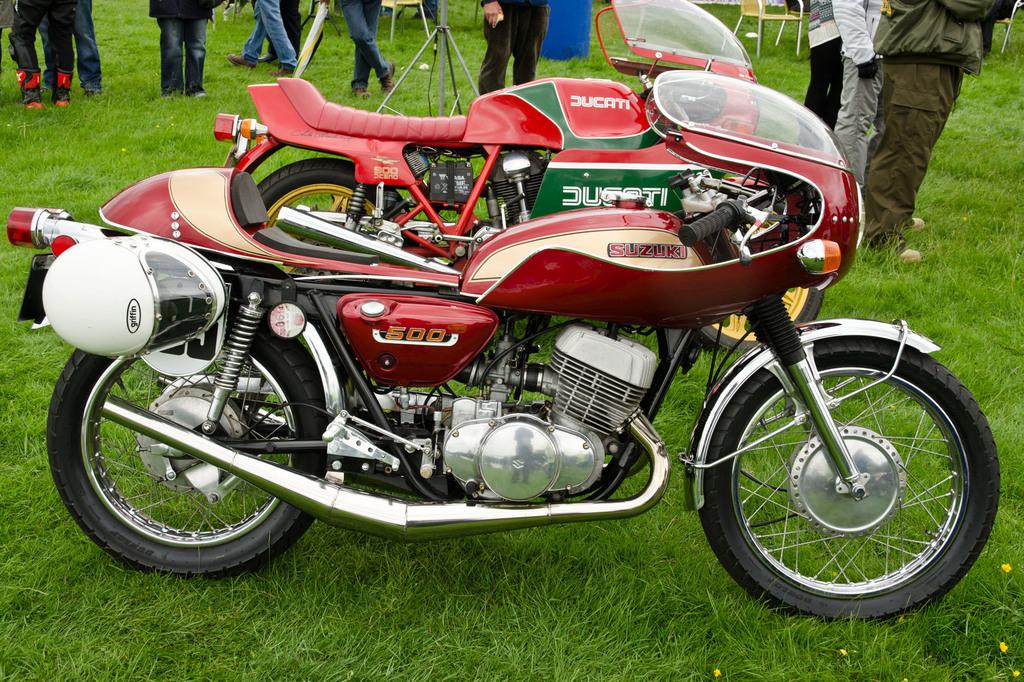Where was the image taken? The image was clicked outside. What type of terrain is visible in the image? There is grass in the image. How many people are standing at the top in the image? There are multiple persons standing at the top. What object can be seen in the middle of the image? There is a bike in the middle of the image. What color of paint is used to decorate the island in the image? There is no island present in the image, so there is no paint to be considered. How is the connection between the persons at the top established in the image? The image does not show any connections between the persons; they are simply standing near each other. 